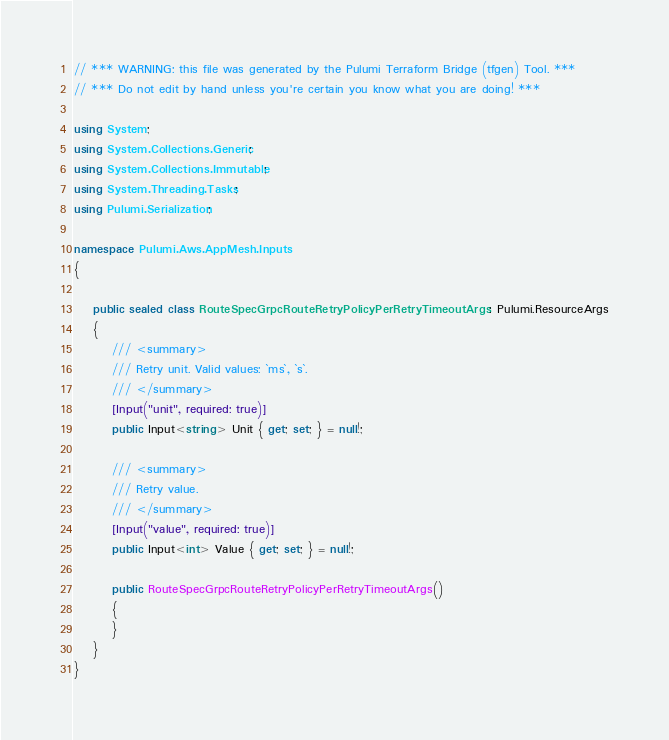Convert code to text. <code><loc_0><loc_0><loc_500><loc_500><_C#_>// *** WARNING: this file was generated by the Pulumi Terraform Bridge (tfgen) Tool. ***
// *** Do not edit by hand unless you're certain you know what you are doing! ***

using System;
using System.Collections.Generic;
using System.Collections.Immutable;
using System.Threading.Tasks;
using Pulumi.Serialization;

namespace Pulumi.Aws.AppMesh.Inputs
{

    public sealed class RouteSpecGrpcRouteRetryPolicyPerRetryTimeoutArgs : Pulumi.ResourceArgs
    {
        /// <summary>
        /// Retry unit. Valid values: `ms`, `s`.
        /// </summary>
        [Input("unit", required: true)]
        public Input<string> Unit { get; set; } = null!;

        /// <summary>
        /// Retry value.
        /// </summary>
        [Input("value", required: true)]
        public Input<int> Value { get; set; } = null!;

        public RouteSpecGrpcRouteRetryPolicyPerRetryTimeoutArgs()
        {
        }
    }
}
</code> 